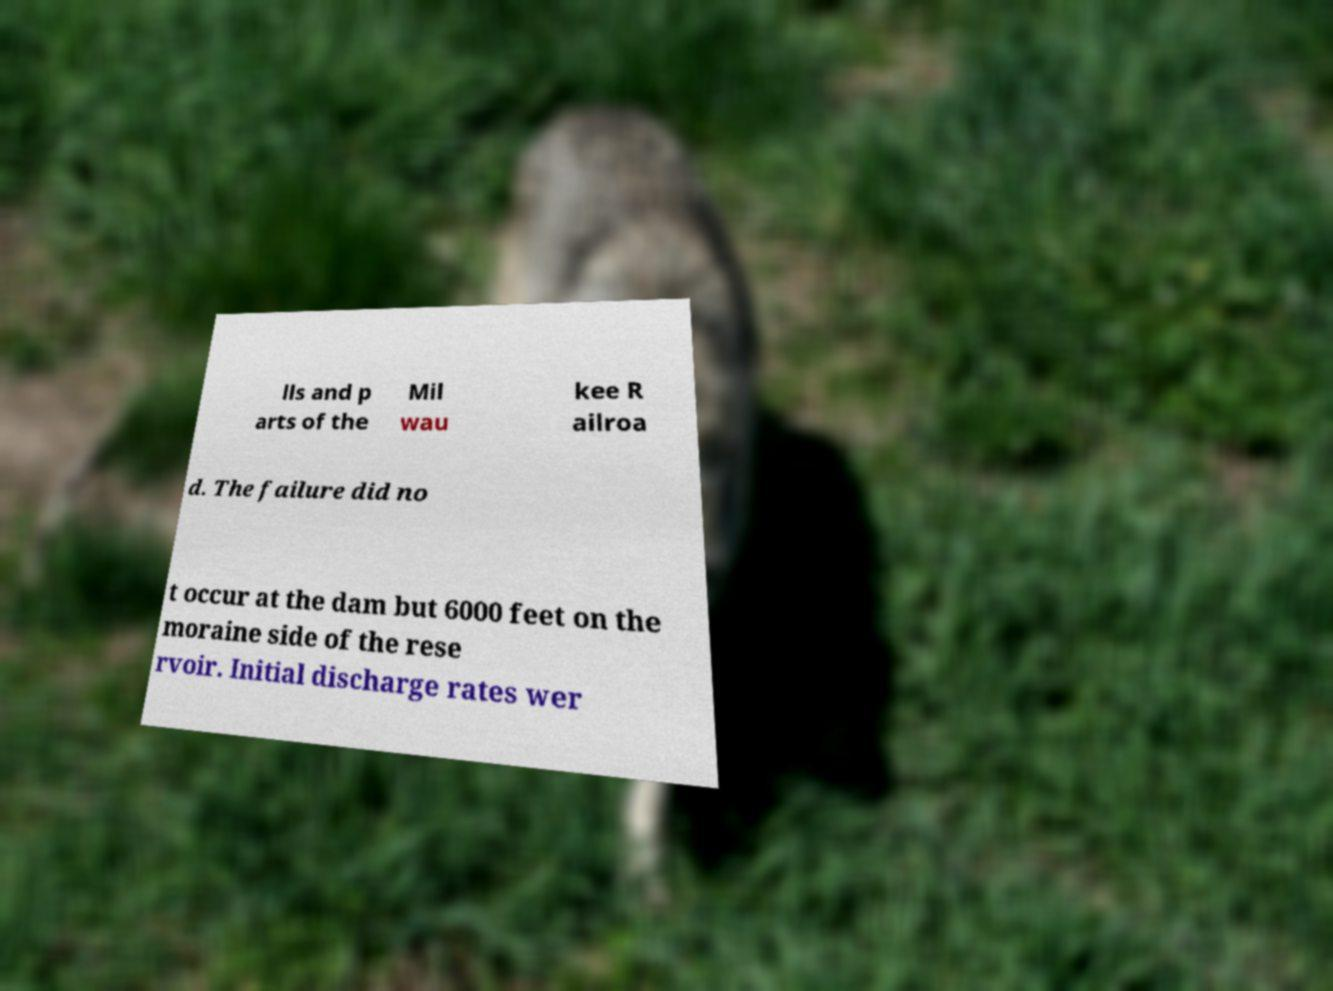I need the written content from this picture converted into text. Can you do that? lls and p arts of the Mil wau kee R ailroa d. The failure did no t occur at the dam but 6000 feet on the moraine side of the rese rvoir. Initial discharge rates wer 